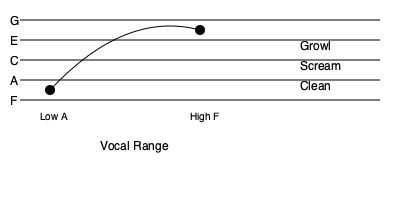Analyze the musical staff and notation provided. What vocal technique is commonly used by Japanese metal vocalists to achieve the extreme high notes represented, and what is the approximate vocal range shown? 1. The musical staff shows a vocal range from low A to high F, spanning approximately two and a half octaves.

2. The curved line represents the typical vocal range of a Japanese metal vocalist, extending from the bottom line (F) to above the top line (high F).

3. Japanese metal vocalists often employ various techniques to achieve this wide range:
   a) Clean singing for mid-range notes
   b) Growls for lower notes
   c) Screams for higher notes

4. To reach the extreme high notes (like the high F shown), many Japanese metal vocalists use a technique called "false cord screaming" or "fry screaming."

5. This technique involves using the false vocal folds to produce a high-pitched, intense sound that can reach notes beyond the typical vocal range.

6. The approximate vocal range shown in the staff is from A2 (low A) to F5 (high F), which is about two and a half octaves.

7. This range is considered quite wide and is characteristic of many Japanese metal vocalists, allowing them to perform both deep, guttural sounds and piercing high notes within the same song.
Answer: False cord screaming; A2 to F5 (2.5 octaves) 